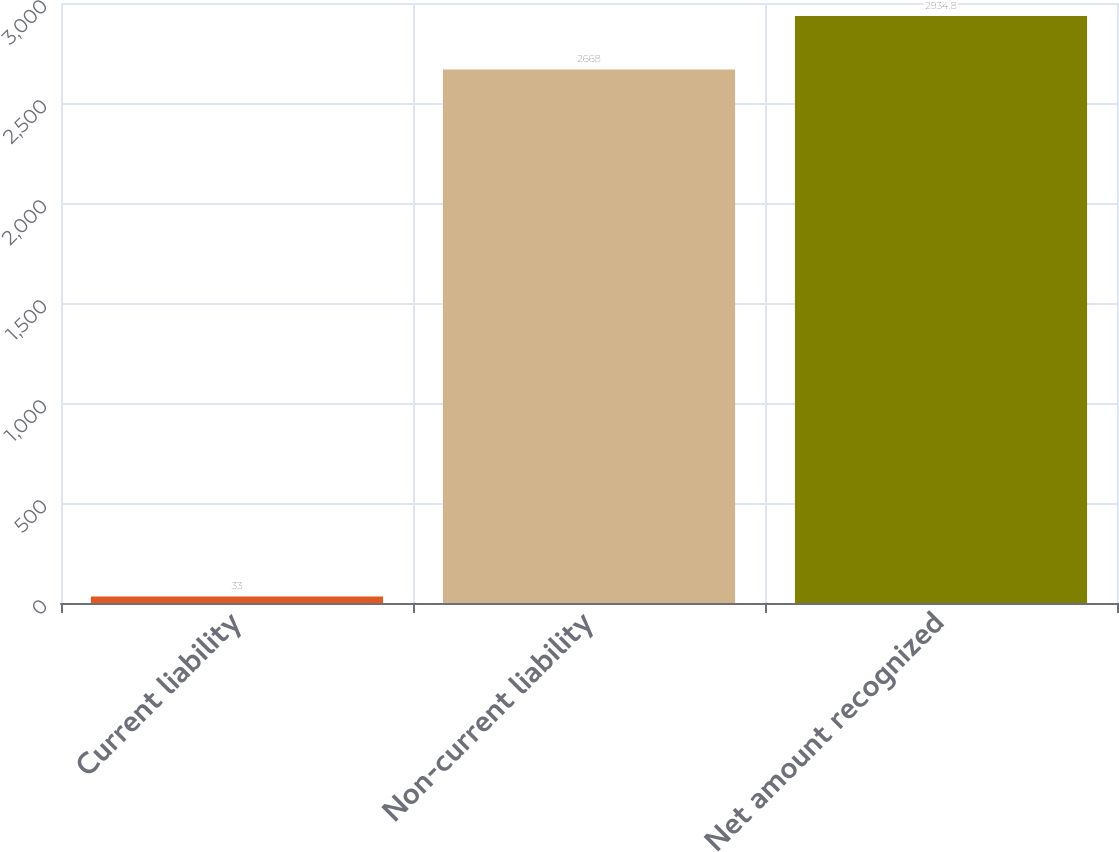Convert chart to OTSL. <chart><loc_0><loc_0><loc_500><loc_500><bar_chart><fcel>Current liability<fcel>Non-current liability<fcel>Net amount recognized<nl><fcel>33<fcel>2668<fcel>2934.8<nl></chart> 